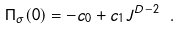<formula> <loc_0><loc_0><loc_500><loc_500>\Pi _ { \sigma } ( 0 ) = - c _ { 0 } + c _ { 1 } J ^ { D - 2 } \ .</formula> 